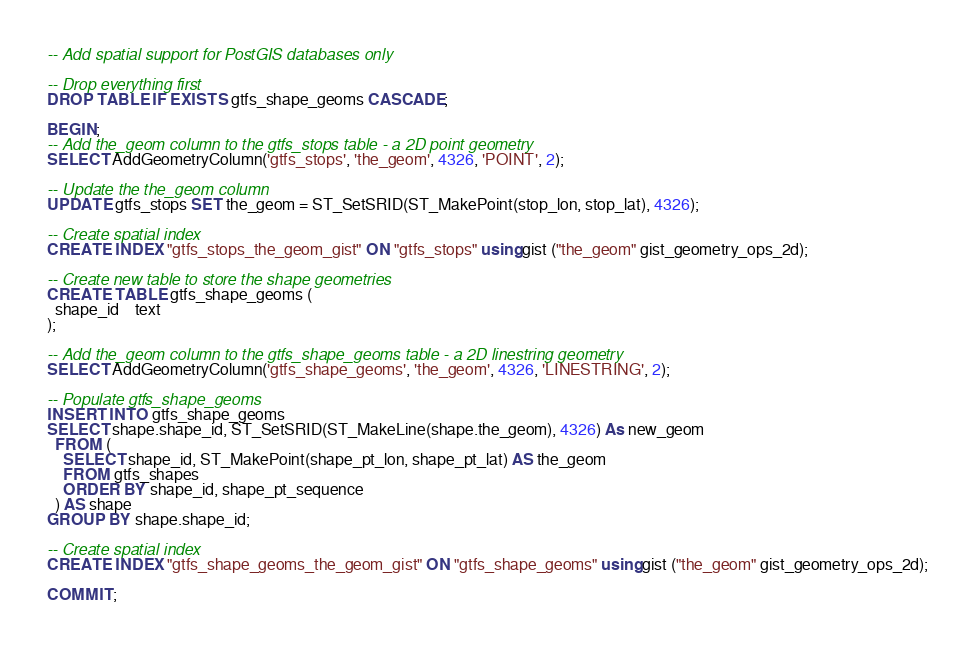<code> <loc_0><loc_0><loc_500><loc_500><_SQL_>-- Add spatial support for PostGIS databases only

-- Drop everything first
DROP TABLE IF EXISTS gtfs_shape_geoms CASCADE;

BEGIN;
-- Add the_geom column to the gtfs_stops table - a 2D point geometry
SELECT AddGeometryColumn('gtfs_stops', 'the_geom', 4326, 'POINT', 2);

-- Update the the_geom column
UPDATE gtfs_stops SET the_geom = ST_SetSRID(ST_MakePoint(stop_lon, stop_lat), 4326);

-- Create spatial index
CREATE INDEX "gtfs_stops_the_geom_gist" ON "gtfs_stops" using gist ("the_geom" gist_geometry_ops_2d);

-- Create new table to store the shape geometries
CREATE TABLE gtfs_shape_geoms (
  shape_id    text
);

-- Add the_geom column to the gtfs_shape_geoms table - a 2D linestring geometry
SELECT AddGeometryColumn('gtfs_shape_geoms', 'the_geom', 4326, 'LINESTRING', 2);

-- Populate gtfs_shape_geoms
INSERT INTO gtfs_shape_geoms
SELECT shape.shape_id, ST_SetSRID(ST_MakeLine(shape.the_geom), 4326) As new_geom
  FROM (
    SELECT shape_id, ST_MakePoint(shape_pt_lon, shape_pt_lat) AS the_geom
    FROM gtfs_shapes 
    ORDER BY shape_id, shape_pt_sequence
  ) AS shape
GROUP BY shape.shape_id;

-- Create spatial index
CREATE INDEX "gtfs_shape_geoms_the_geom_gist" ON "gtfs_shape_geoms" using gist ("the_geom" gist_geometry_ops_2d);

COMMIT;</code> 